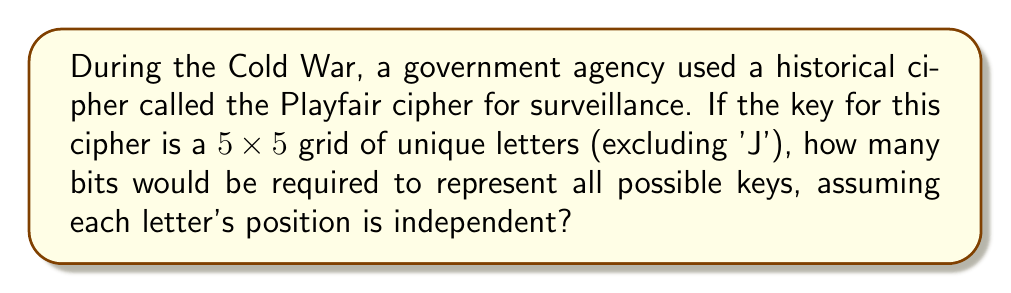Could you help me with this problem? To calculate the key length in bits, we need to determine the number of possible keys and then convert that to bits. Let's break it down step-by-step:

1. The Playfair cipher uses a 5x5 grid with 25 unique letters (excluding 'J').

2. For the first position, we have 25 choices.
   For the second position, we have 24 choices.
   For the third position, we have 23 choices, and so on.

3. The total number of possible arrangements is:
   $$ 25 \times 24 \times 23 \times 22 \times ... \times 2 \times 1 = 25! $$

4. To convert this to bits, we use the formula:
   $$ \text{bits} = \log_2(25!) $$

5. Using a calculator or computer, we can calculate this:
   $$ \log_2(25!) \approx 83.048... $$

6. Since we need a whole number of bits, we round up to the nearest integer:
   $$ \lceil 83.048... \rceil = 84 $$

Therefore, 84 bits would be required to represent all possible keys for the Playfair cipher.
Answer: 84 bits 